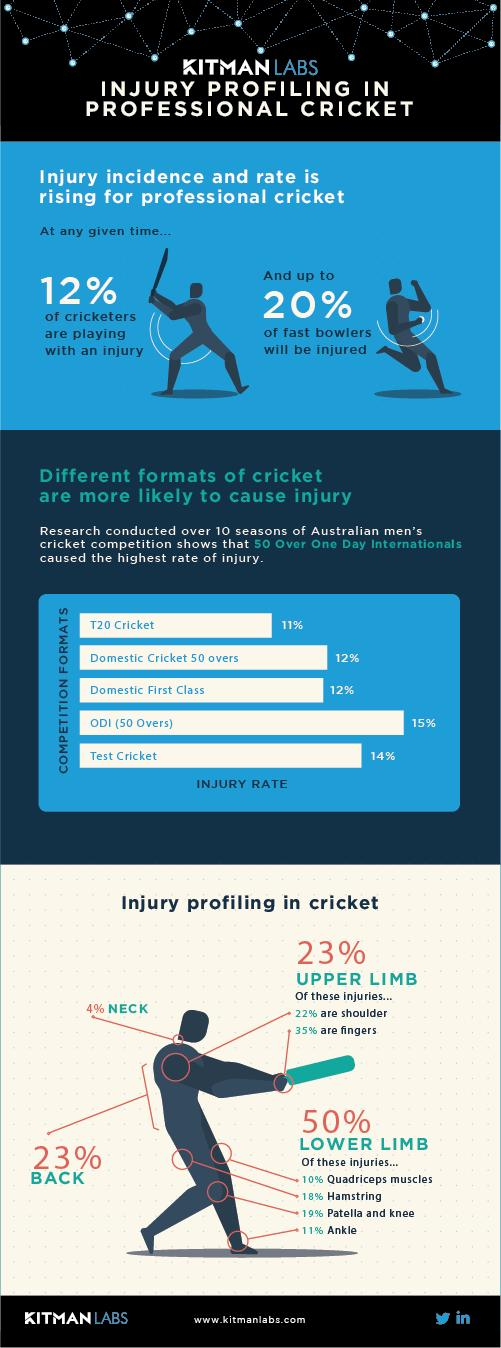Identify some key points in this picture. Lower limbs are more prone to injuries. In domestic cricket and domestic first class cricket, a rate of 12% was recorded for injuries. 